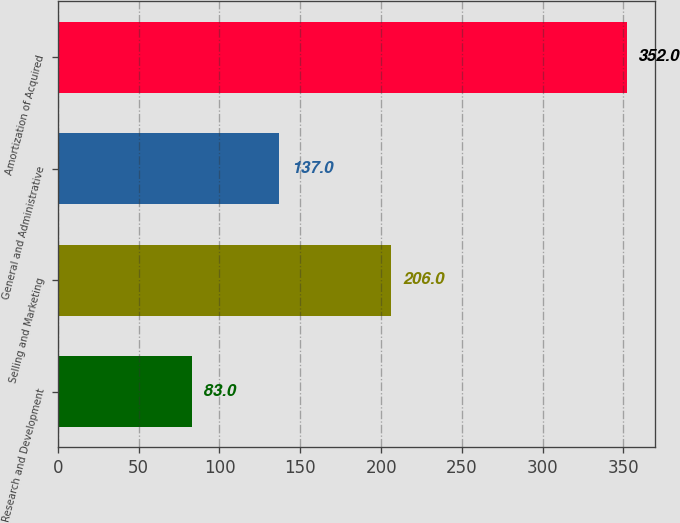<chart> <loc_0><loc_0><loc_500><loc_500><bar_chart><fcel>Research and Development<fcel>Selling and Marketing<fcel>General and Administrative<fcel>Amortization of Acquired<nl><fcel>83<fcel>206<fcel>137<fcel>352<nl></chart> 